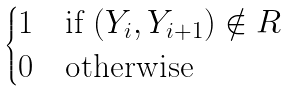<formula> <loc_0><loc_0><loc_500><loc_500>\begin{cases} 1 & \text {if    } ( Y _ { i } , Y _ { i + 1 } ) \notin R \\ 0 & \text {otherwise} \end{cases}</formula> 